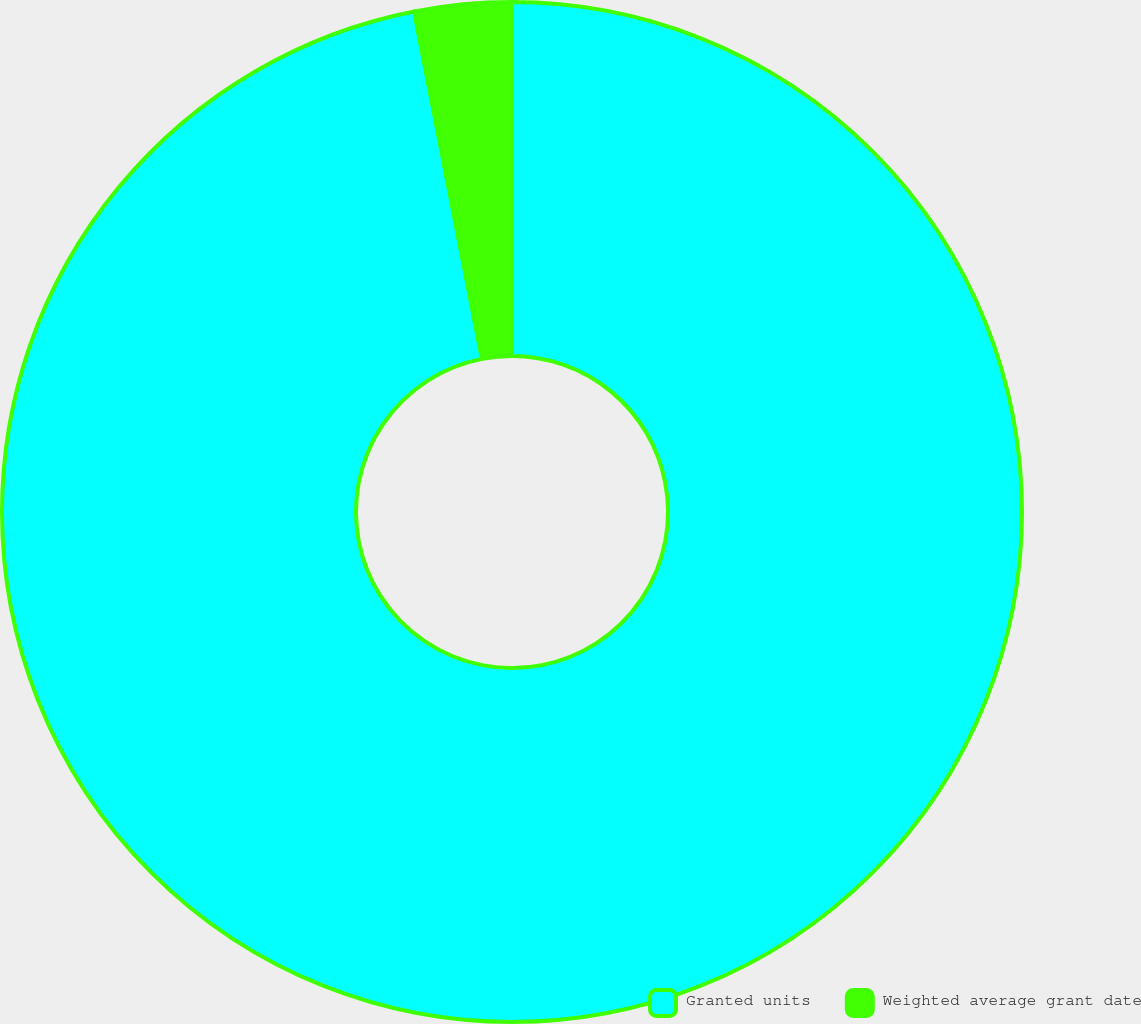Convert chart to OTSL. <chart><loc_0><loc_0><loc_500><loc_500><pie_chart><fcel>Granted units<fcel>Weighted average grant date<nl><fcel>96.93%<fcel>3.07%<nl></chart> 